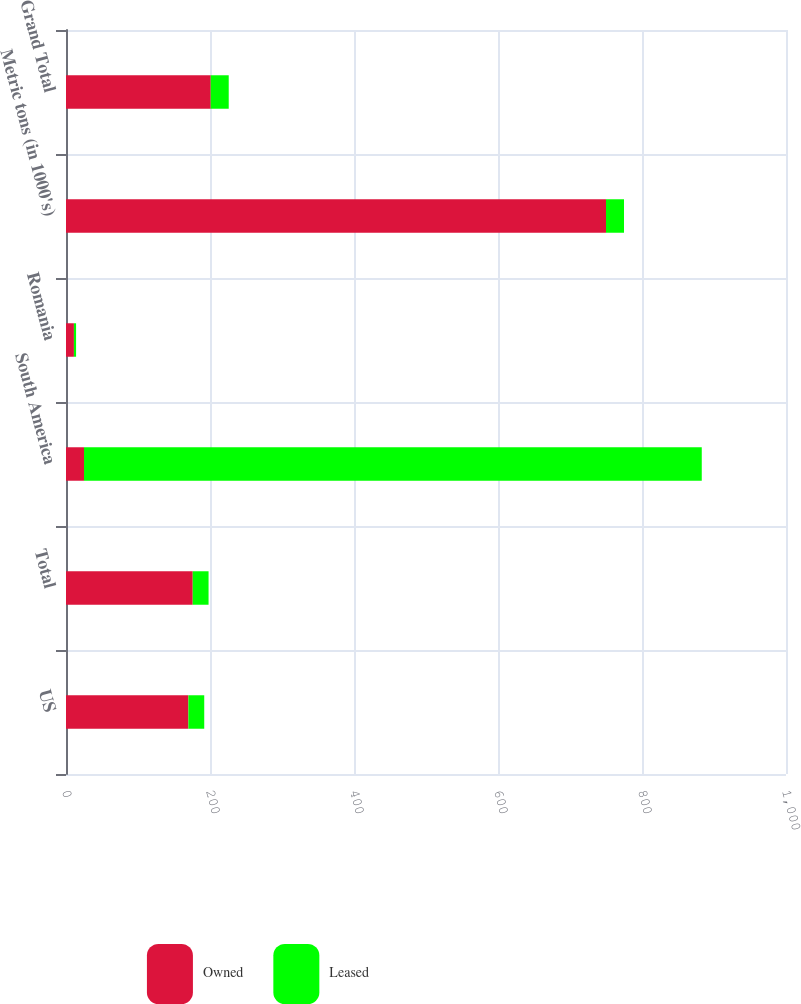Convert chart. <chart><loc_0><loc_0><loc_500><loc_500><stacked_bar_chart><ecel><fcel>US<fcel>Total<fcel>South America<fcel>Romania<fcel>Metric tons (in 1000's)<fcel>Grand Total<nl><fcel>Owned<fcel>170<fcel>176<fcel>25<fcel>11<fcel>750<fcel>201<nl><fcel>Leased<fcel>22<fcel>22<fcel>858<fcel>3<fcel>25<fcel>25<nl></chart> 